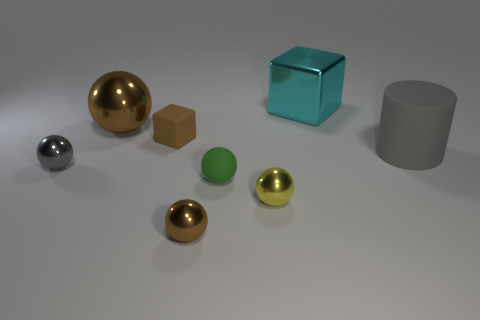The tiny cube is what color?
Provide a short and direct response. Brown. How many cyan blocks are made of the same material as the tiny yellow sphere?
Provide a short and direct response. 1. How many small shiny objects are behind the gray cylinder?
Provide a short and direct response. 0. Is the material of the brown sphere behind the small yellow sphere the same as the cube that is on the left side of the tiny yellow metallic thing?
Your answer should be very brief. No. Is the number of small brown metal balls in front of the metallic cube greater than the number of small brown spheres in front of the large cylinder?
Make the answer very short. No. What material is the tiny object that is the same color as the small rubber cube?
Ensure brevity in your answer.  Metal. Is there anything else that is the same shape as the small brown matte object?
Ensure brevity in your answer.  Yes. The large object that is both right of the large sphere and behind the large matte object is made of what material?
Your answer should be compact. Metal. Is the material of the yellow object the same as the gray object right of the brown cube?
Provide a succinct answer. No. What number of objects are either brown shiny spheres or big metallic spheres left of the tiny brown shiny object?
Offer a terse response. 2. 